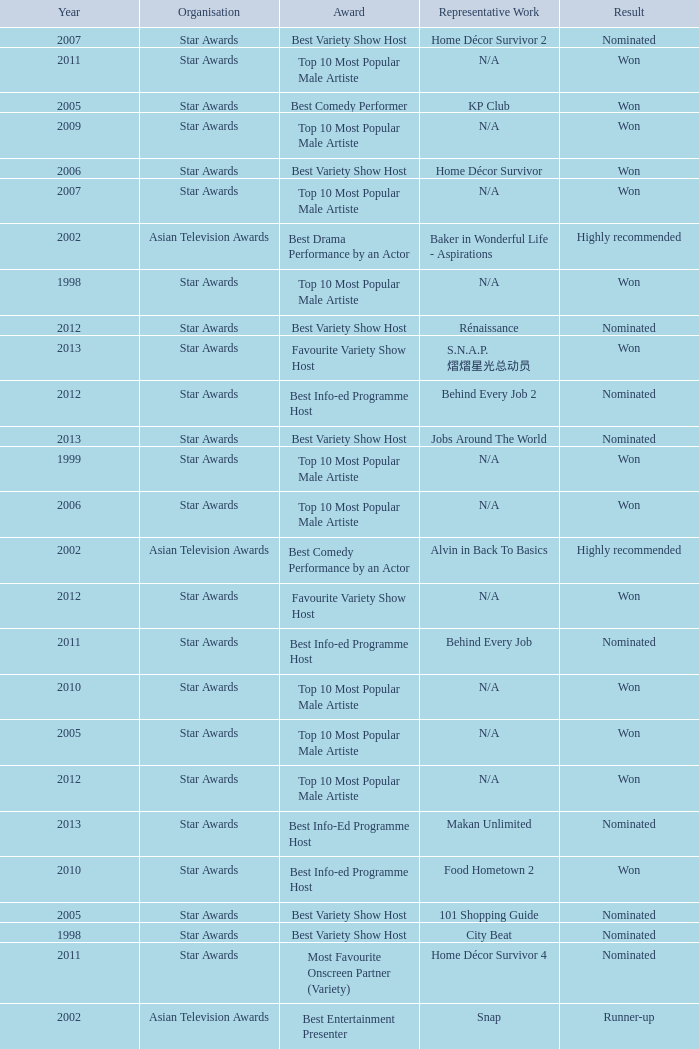What is the name of the award in a year more than 2005, and the Result of nominated? Best Variety Show Host, Most Favourite Onscreen Partner (Variety), Best Variety Show Host, Best Info-ed Programme Host, Best Variety Show Host, Best Info-ed Programme Host, Best Info-Ed Programme Host, Best Variety Show Host. 